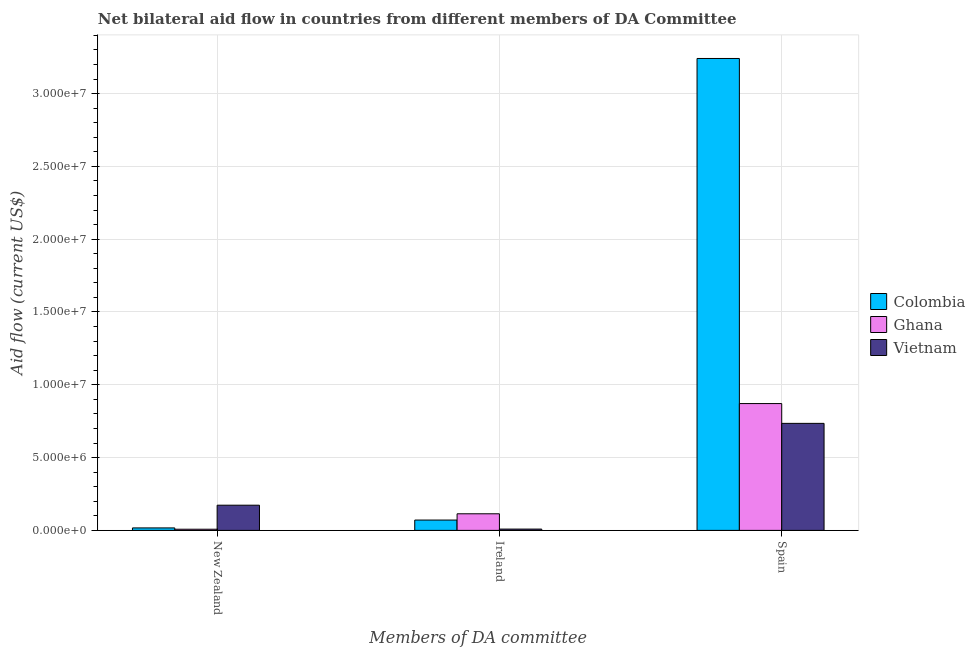How many different coloured bars are there?
Provide a succinct answer. 3. How many groups of bars are there?
Your answer should be very brief. 3. Are the number of bars on each tick of the X-axis equal?
Ensure brevity in your answer.  Yes. How many bars are there on the 1st tick from the left?
Keep it short and to the point. 3. What is the label of the 1st group of bars from the left?
Your answer should be very brief. New Zealand. What is the amount of aid provided by ireland in Vietnam?
Your answer should be very brief. 9.00e+04. Across all countries, what is the maximum amount of aid provided by spain?
Your answer should be compact. 3.24e+07. Across all countries, what is the minimum amount of aid provided by ireland?
Your answer should be compact. 9.00e+04. In which country was the amount of aid provided by spain maximum?
Your response must be concise. Colombia. In which country was the amount of aid provided by ireland minimum?
Provide a short and direct response. Vietnam. What is the total amount of aid provided by spain in the graph?
Offer a terse response. 4.85e+07. What is the difference between the amount of aid provided by new zealand in Colombia and that in Vietnam?
Offer a terse response. -1.56e+06. What is the difference between the amount of aid provided by ireland in Vietnam and the amount of aid provided by spain in Ghana?
Offer a terse response. -8.62e+06. What is the average amount of aid provided by spain per country?
Your answer should be very brief. 1.62e+07. What is the difference between the amount of aid provided by new zealand and amount of aid provided by ireland in Vietnam?
Your response must be concise. 1.64e+06. In how many countries, is the amount of aid provided by new zealand greater than 26000000 US$?
Provide a succinct answer. 0. What is the ratio of the amount of aid provided by ireland in Colombia to that in Vietnam?
Give a very brief answer. 7.89. What is the difference between the highest and the second highest amount of aid provided by spain?
Your answer should be compact. 2.37e+07. What is the difference between the highest and the lowest amount of aid provided by ireland?
Offer a very short reply. 1.05e+06. Is the sum of the amount of aid provided by new zealand in Vietnam and Colombia greater than the maximum amount of aid provided by ireland across all countries?
Provide a succinct answer. Yes. What does the 1st bar from the left in Spain represents?
Keep it short and to the point. Colombia. What does the 3rd bar from the right in Spain represents?
Offer a very short reply. Colombia. Are all the bars in the graph horizontal?
Ensure brevity in your answer.  No. Are the values on the major ticks of Y-axis written in scientific E-notation?
Give a very brief answer. Yes. Where does the legend appear in the graph?
Your answer should be compact. Center right. How many legend labels are there?
Your answer should be compact. 3. What is the title of the graph?
Offer a very short reply. Net bilateral aid flow in countries from different members of DA Committee. Does "Guinea-Bissau" appear as one of the legend labels in the graph?
Your answer should be very brief. No. What is the label or title of the X-axis?
Provide a succinct answer. Members of DA committee. What is the label or title of the Y-axis?
Your answer should be very brief. Aid flow (current US$). What is the Aid flow (current US$) in Ghana in New Zealand?
Offer a very short reply. 8.00e+04. What is the Aid flow (current US$) of Vietnam in New Zealand?
Provide a succinct answer. 1.73e+06. What is the Aid flow (current US$) of Colombia in Ireland?
Offer a very short reply. 7.10e+05. What is the Aid flow (current US$) of Ghana in Ireland?
Provide a short and direct response. 1.14e+06. What is the Aid flow (current US$) in Vietnam in Ireland?
Provide a short and direct response. 9.00e+04. What is the Aid flow (current US$) in Colombia in Spain?
Offer a terse response. 3.24e+07. What is the Aid flow (current US$) of Ghana in Spain?
Your answer should be very brief. 8.71e+06. What is the Aid flow (current US$) in Vietnam in Spain?
Offer a very short reply. 7.35e+06. Across all Members of DA committee, what is the maximum Aid flow (current US$) of Colombia?
Ensure brevity in your answer.  3.24e+07. Across all Members of DA committee, what is the maximum Aid flow (current US$) in Ghana?
Your response must be concise. 8.71e+06. Across all Members of DA committee, what is the maximum Aid flow (current US$) of Vietnam?
Offer a very short reply. 7.35e+06. Across all Members of DA committee, what is the minimum Aid flow (current US$) of Ghana?
Make the answer very short. 8.00e+04. What is the total Aid flow (current US$) of Colombia in the graph?
Make the answer very short. 3.33e+07. What is the total Aid flow (current US$) of Ghana in the graph?
Provide a succinct answer. 9.93e+06. What is the total Aid flow (current US$) of Vietnam in the graph?
Your answer should be very brief. 9.17e+06. What is the difference between the Aid flow (current US$) of Colombia in New Zealand and that in Ireland?
Ensure brevity in your answer.  -5.40e+05. What is the difference between the Aid flow (current US$) in Ghana in New Zealand and that in Ireland?
Your answer should be compact. -1.06e+06. What is the difference between the Aid flow (current US$) in Vietnam in New Zealand and that in Ireland?
Keep it short and to the point. 1.64e+06. What is the difference between the Aid flow (current US$) of Colombia in New Zealand and that in Spain?
Provide a succinct answer. -3.22e+07. What is the difference between the Aid flow (current US$) in Ghana in New Zealand and that in Spain?
Ensure brevity in your answer.  -8.63e+06. What is the difference between the Aid flow (current US$) in Vietnam in New Zealand and that in Spain?
Give a very brief answer. -5.62e+06. What is the difference between the Aid flow (current US$) in Colombia in Ireland and that in Spain?
Your response must be concise. -3.17e+07. What is the difference between the Aid flow (current US$) of Ghana in Ireland and that in Spain?
Give a very brief answer. -7.57e+06. What is the difference between the Aid flow (current US$) of Vietnam in Ireland and that in Spain?
Keep it short and to the point. -7.26e+06. What is the difference between the Aid flow (current US$) in Colombia in New Zealand and the Aid flow (current US$) in Ghana in Ireland?
Ensure brevity in your answer.  -9.70e+05. What is the difference between the Aid flow (current US$) in Colombia in New Zealand and the Aid flow (current US$) in Vietnam in Ireland?
Your response must be concise. 8.00e+04. What is the difference between the Aid flow (current US$) of Colombia in New Zealand and the Aid flow (current US$) of Ghana in Spain?
Give a very brief answer. -8.54e+06. What is the difference between the Aid flow (current US$) of Colombia in New Zealand and the Aid flow (current US$) of Vietnam in Spain?
Your response must be concise. -7.18e+06. What is the difference between the Aid flow (current US$) of Ghana in New Zealand and the Aid flow (current US$) of Vietnam in Spain?
Provide a succinct answer. -7.27e+06. What is the difference between the Aid flow (current US$) of Colombia in Ireland and the Aid flow (current US$) of Ghana in Spain?
Keep it short and to the point. -8.00e+06. What is the difference between the Aid flow (current US$) of Colombia in Ireland and the Aid flow (current US$) of Vietnam in Spain?
Give a very brief answer. -6.64e+06. What is the difference between the Aid flow (current US$) in Ghana in Ireland and the Aid flow (current US$) in Vietnam in Spain?
Keep it short and to the point. -6.21e+06. What is the average Aid flow (current US$) of Colombia per Members of DA committee?
Provide a short and direct response. 1.11e+07. What is the average Aid flow (current US$) in Ghana per Members of DA committee?
Make the answer very short. 3.31e+06. What is the average Aid flow (current US$) of Vietnam per Members of DA committee?
Ensure brevity in your answer.  3.06e+06. What is the difference between the Aid flow (current US$) of Colombia and Aid flow (current US$) of Ghana in New Zealand?
Provide a succinct answer. 9.00e+04. What is the difference between the Aid flow (current US$) of Colombia and Aid flow (current US$) of Vietnam in New Zealand?
Offer a terse response. -1.56e+06. What is the difference between the Aid flow (current US$) of Ghana and Aid flow (current US$) of Vietnam in New Zealand?
Provide a short and direct response. -1.65e+06. What is the difference between the Aid flow (current US$) in Colombia and Aid flow (current US$) in Ghana in Ireland?
Give a very brief answer. -4.30e+05. What is the difference between the Aid flow (current US$) in Colombia and Aid flow (current US$) in Vietnam in Ireland?
Your answer should be very brief. 6.20e+05. What is the difference between the Aid flow (current US$) of Ghana and Aid flow (current US$) of Vietnam in Ireland?
Keep it short and to the point. 1.05e+06. What is the difference between the Aid flow (current US$) in Colombia and Aid flow (current US$) in Ghana in Spain?
Keep it short and to the point. 2.37e+07. What is the difference between the Aid flow (current US$) in Colombia and Aid flow (current US$) in Vietnam in Spain?
Keep it short and to the point. 2.51e+07. What is the difference between the Aid flow (current US$) of Ghana and Aid flow (current US$) of Vietnam in Spain?
Ensure brevity in your answer.  1.36e+06. What is the ratio of the Aid flow (current US$) of Colombia in New Zealand to that in Ireland?
Your response must be concise. 0.24. What is the ratio of the Aid flow (current US$) of Ghana in New Zealand to that in Ireland?
Keep it short and to the point. 0.07. What is the ratio of the Aid flow (current US$) in Vietnam in New Zealand to that in Ireland?
Provide a succinct answer. 19.22. What is the ratio of the Aid flow (current US$) in Colombia in New Zealand to that in Spain?
Ensure brevity in your answer.  0.01. What is the ratio of the Aid flow (current US$) of Ghana in New Zealand to that in Spain?
Offer a terse response. 0.01. What is the ratio of the Aid flow (current US$) in Vietnam in New Zealand to that in Spain?
Offer a very short reply. 0.24. What is the ratio of the Aid flow (current US$) of Colombia in Ireland to that in Spain?
Keep it short and to the point. 0.02. What is the ratio of the Aid flow (current US$) of Ghana in Ireland to that in Spain?
Your answer should be very brief. 0.13. What is the ratio of the Aid flow (current US$) of Vietnam in Ireland to that in Spain?
Your answer should be very brief. 0.01. What is the difference between the highest and the second highest Aid flow (current US$) in Colombia?
Your answer should be compact. 3.17e+07. What is the difference between the highest and the second highest Aid flow (current US$) in Ghana?
Your answer should be very brief. 7.57e+06. What is the difference between the highest and the second highest Aid flow (current US$) of Vietnam?
Make the answer very short. 5.62e+06. What is the difference between the highest and the lowest Aid flow (current US$) in Colombia?
Your answer should be compact. 3.22e+07. What is the difference between the highest and the lowest Aid flow (current US$) in Ghana?
Give a very brief answer. 8.63e+06. What is the difference between the highest and the lowest Aid flow (current US$) in Vietnam?
Your answer should be compact. 7.26e+06. 